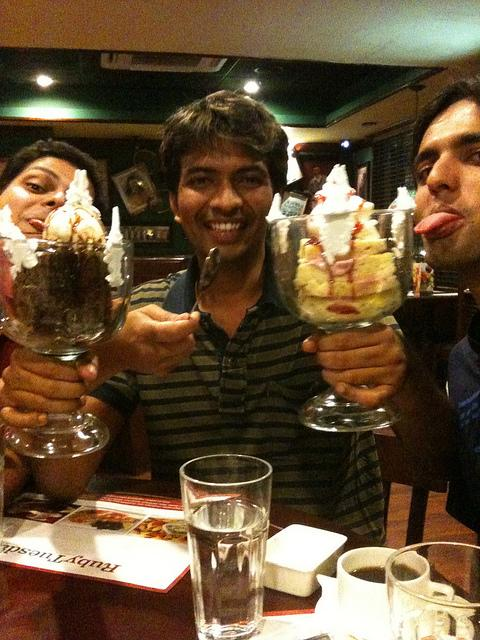In what year did this company exit bankruptcy?

Choices:
A) 2016
B) 2014
C) 2008
D) 2021 2021 